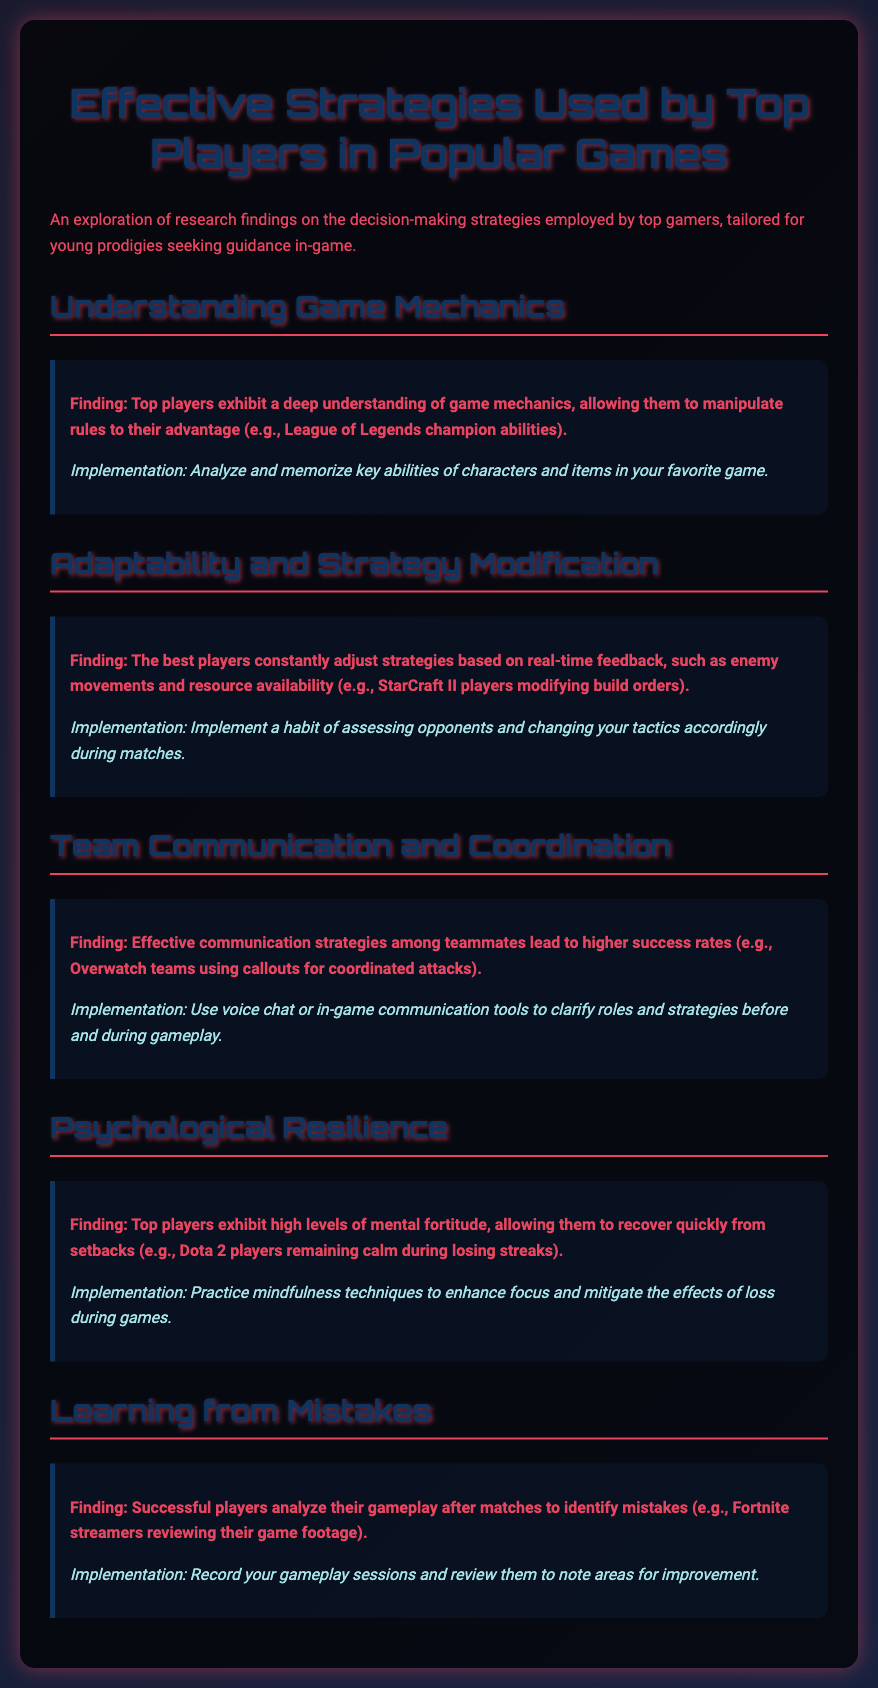What is the title of the document? The title of the document is specified in the header section, which is "Effective Strategies for Top Players in Popular Games."
Answer: Effective Strategies for Top Players in Popular Games What is one key finding about understanding game mechanics? The document lists one key finding that mentions top players understand game mechanics, which is exemplified by League of Legends champion abilities.
Answer: Deep understanding of game mechanics What communication tool is suggested for team coordination? The document suggests using voice chat or in-game communication tools to enhance clarity among teammates.
Answer: Voice chat What is a psychological aspect mentioned in the findings? The document highlights that top players exhibit high levels of mental fortitude, helping them recover from setbacks.
Answer: Mental fortitude Which game is mentioned as an example of players modifying strategies? StarCraft II is referenced as an example where players adjust their strategies based on real-time feedback.
Answer: StarCraft II What practice is suggested to learn from mistakes? Recording gameplay sessions is recommended for players to analyze their mistakes afterward.
Answer: Record your gameplay sessions How can players enhance their focus according to the findings? The document suggests practicing mindfulness techniques to improve focus during gaming.
Answer: Mindfulness techniques 